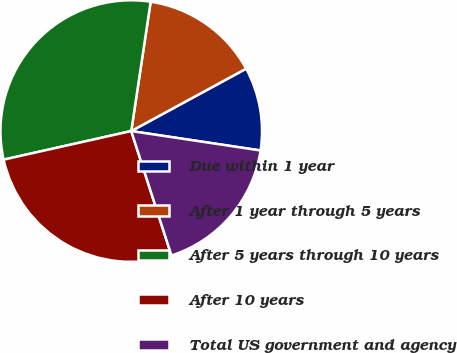Convert chart. <chart><loc_0><loc_0><loc_500><loc_500><pie_chart><fcel>Due within 1 year<fcel>After 1 year through 5 years<fcel>After 5 years through 10 years<fcel>After 10 years<fcel>Total US government and agency<nl><fcel>10.29%<fcel>14.71%<fcel>30.88%<fcel>26.47%<fcel>17.65%<nl></chart> 